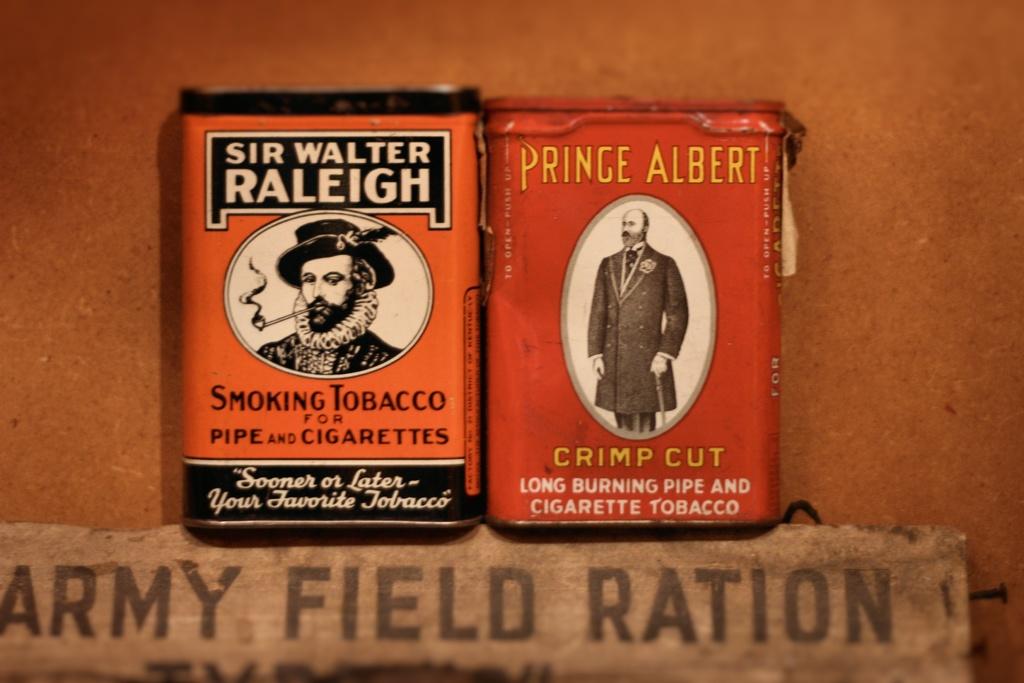What are the three words under the cigarette packets?
Your answer should be very brief. Army field ration. 